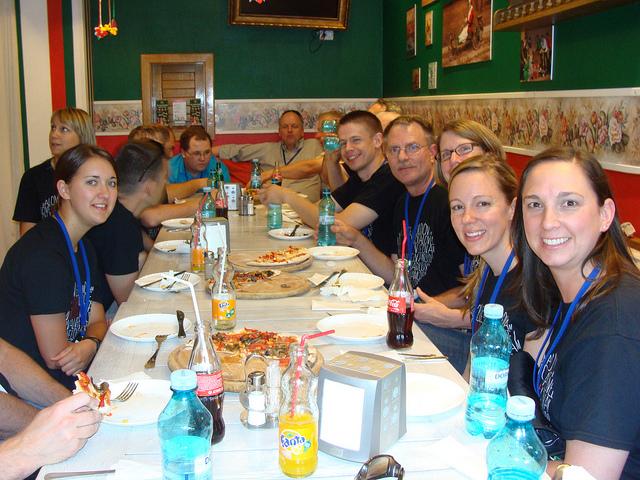Is everyone looking at the camera?
Answer briefly. No. Are there a group of people sitting together eating at a restaurant in this picture?
Quick response, please. Yes. How many blue bottles are on the table?
Quick response, please. 8. 